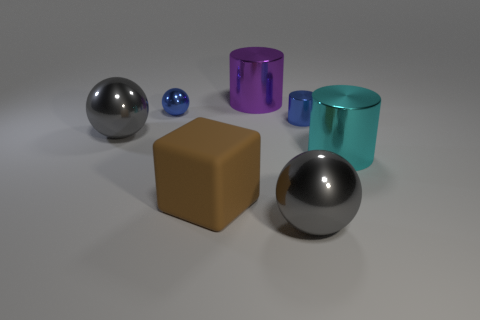Subtract all gray cylinders. Subtract all green blocks. How many cylinders are left? 3 Add 2 gray objects. How many objects exist? 9 Subtract all cylinders. How many objects are left? 4 Subtract 0 purple balls. How many objects are left? 7 Subtract all large cyan shiny cylinders. Subtract all big metallic spheres. How many objects are left? 4 Add 7 big cyan shiny cylinders. How many big cyan shiny cylinders are left? 8 Add 2 spheres. How many spheres exist? 5 